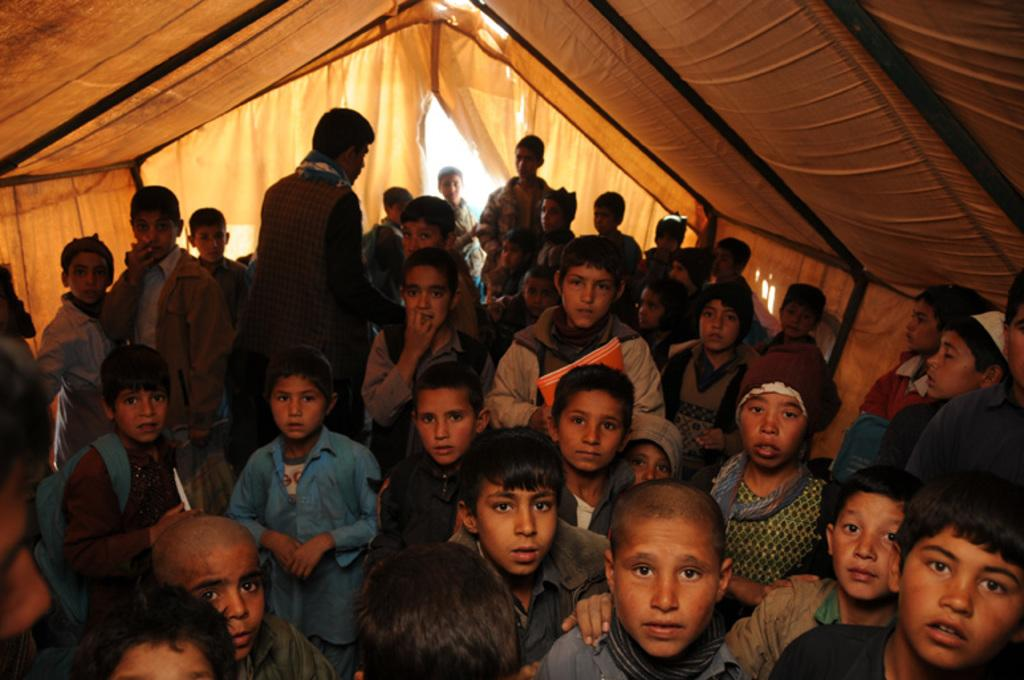How many people are in the image? There is a group of people in the image, but the exact number cannot be determined from the provided facts. Where are the people located in the image? The people are inside a tent in the image. What else can be seen in the image besides the people? There are objects present in the image, but their specific nature cannot be determined from the provided facts. Why are the people in the image crying? There is no indication in the image that the people are crying. The provided facts only mention that there is a group of people inside a tent, and there are objects present in the image. 